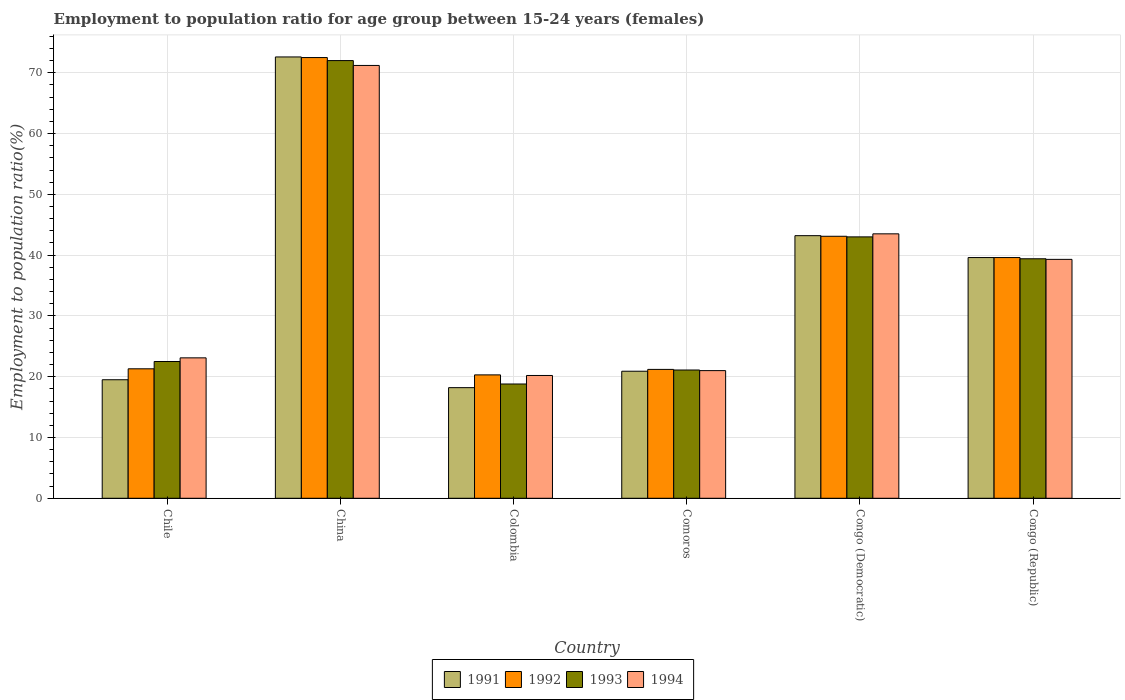Are the number of bars per tick equal to the number of legend labels?
Your answer should be compact. Yes. How many bars are there on the 2nd tick from the left?
Offer a terse response. 4. How many bars are there on the 6th tick from the right?
Your answer should be compact. 4. What is the label of the 1st group of bars from the left?
Make the answer very short. Chile. In how many cases, is the number of bars for a given country not equal to the number of legend labels?
Provide a short and direct response. 0. Across all countries, what is the maximum employment to population ratio in 1991?
Provide a short and direct response. 72.6. Across all countries, what is the minimum employment to population ratio in 1994?
Your answer should be compact. 20.2. In which country was the employment to population ratio in 1992 maximum?
Provide a succinct answer. China. What is the total employment to population ratio in 1994 in the graph?
Ensure brevity in your answer.  218.3. What is the difference between the employment to population ratio in 1993 in China and that in Congo (Republic)?
Keep it short and to the point. 32.6. What is the difference between the employment to population ratio in 1993 in China and the employment to population ratio in 1992 in Chile?
Ensure brevity in your answer.  50.7. What is the average employment to population ratio in 1991 per country?
Provide a short and direct response. 35.67. What is the difference between the employment to population ratio of/in 1994 and employment to population ratio of/in 1991 in China?
Ensure brevity in your answer.  -1.4. What is the ratio of the employment to population ratio in 1994 in Congo (Democratic) to that in Congo (Republic)?
Your answer should be compact. 1.11. Is the difference between the employment to population ratio in 1994 in Chile and Congo (Republic) greater than the difference between the employment to population ratio in 1991 in Chile and Congo (Republic)?
Your answer should be very brief. Yes. What is the difference between the highest and the second highest employment to population ratio in 1991?
Give a very brief answer. 29.4. What is the difference between the highest and the lowest employment to population ratio in 1993?
Provide a short and direct response. 53.2. In how many countries, is the employment to population ratio in 1992 greater than the average employment to population ratio in 1992 taken over all countries?
Give a very brief answer. 3. Is the sum of the employment to population ratio in 1994 in China and Congo (Republic) greater than the maximum employment to population ratio in 1992 across all countries?
Offer a very short reply. Yes. Is it the case that in every country, the sum of the employment to population ratio in 1991 and employment to population ratio in 1994 is greater than the employment to population ratio in 1993?
Make the answer very short. Yes. How many bars are there?
Offer a terse response. 24. What is the difference between two consecutive major ticks on the Y-axis?
Provide a short and direct response. 10. Are the values on the major ticks of Y-axis written in scientific E-notation?
Ensure brevity in your answer.  No. Where does the legend appear in the graph?
Provide a short and direct response. Bottom center. How many legend labels are there?
Your response must be concise. 4. How are the legend labels stacked?
Offer a terse response. Horizontal. What is the title of the graph?
Ensure brevity in your answer.  Employment to population ratio for age group between 15-24 years (females). What is the Employment to population ratio(%) of 1992 in Chile?
Provide a short and direct response. 21.3. What is the Employment to population ratio(%) of 1994 in Chile?
Your response must be concise. 23.1. What is the Employment to population ratio(%) of 1991 in China?
Your answer should be very brief. 72.6. What is the Employment to population ratio(%) of 1992 in China?
Keep it short and to the point. 72.5. What is the Employment to population ratio(%) of 1993 in China?
Ensure brevity in your answer.  72. What is the Employment to population ratio(%) of 1994 in China?
Your answer should be compact. 71.2. What is the Employment to population ratio(%) of 1991 in Colombia?
Offer a very short reply. 18.2. What is the Employment to population ratio(%) in 1992 in Colombia?
Your response must be concise. 20.3. What is the Employment to population ratio(%) in 1993 in Colombia?
Ensure brevity in your answer.  18.8. What is the Employment to population ratio(%) in 1994 in Colombia?
Give a very brief answer. 20.2. What is the Employment to population ratio(%) in 1991 in Comoros?
Provide a short and direct response. 20.9. What is the Employment to population ratio(%) of 1992 in Comoros?
Give a very brief answer. 21.2. What is the Employment to population ratio(%) of 1993 in Comoros?
Your answer should be very brief. 21.1. What is the Employment to population ratio(%) in 1994 in Comoros?
Make the answer very short. 21. What is the Employment to population ratio(%) in 1991 in Congo (Democratic)?
Keep it short and to the point. 43.2. What is the Employment to population ratio(%) in 1992 in Congo (Democratic)?
Your answer should be compact. 43.1. What is the Employment to population ratio(%) in 1994 in Congo (Democratic)?
Your answer should be very brief. 43.5. What is the Employment to population ratio(%) in 1991 in Congo (Republic)?
Ensure brevity in your answer.  39.6. What is the Employment to population ratio(%) of 1992 in Congo (Republic)?
Offer a very short reply. 39.6. What is the Employment to population ratio(%) in 1993 in Congo (Republic)?
Your response must be concise. 39.4. What is the Employment to population ratio(%) in 1994 in Congo (Republic)?
Offer a terse response. 39.3. Across all countries, what is the maximum Employment to population ratio(%) in 1991?
Give a very brief answer. 72.6. Across all countries, what is the maximum Employment to population ratio(%) in 1992?
Offer a terse response. 72.5. Across all countries, what is the maximum Employment to population ratio(%) in 1994?
Ensure brevity in your answer.  71.2. Across all countries, what is the minimum Employment to population ratio(%) in 1991?
Offer a very short reply. 18.2. Across all countries, what is the minimum Employment to population ratio(%) in 1992?
Keep it short and to the point. 20.3. Across all countries, what is the minimum Employment to population ratio(%) in 1993?
Keep it short and to the point. 18.8. Across all countries, what is the minimum Employment to population ratio(%) of 1994?
Keep it short and to the point. 20.2. What is the total Employment to population ratio(%) of 1991 in the graph?
Your answer should be very brief. 214. What is the total Employment to population ratio(%) in 1992 in the graph?
Your response must be concise. 218. What is the total Employment to population ratio(%) of 1993 in the graph?
Offer a very short reply. 216.8. What is the total Employment to population ratio(%) in 1994 in the graph?
Your answer should be very brief. 218.3. What is the difference between the Employment to population ratio(%) of 1991 in Chile and that in China?
Make the answer very short. -53.1. What is the difference between the Employment to population ratio(%) in 1992 in Chile and that in China?
Offer a terse response. -51.2. What is the difference between the Employment to population ratio(%) of 1993 in Chile and that in China?
Your answer should be compact. -49.5. What is the difference between the Employment to population ratio(%) of 1994 in Chile and that in China?
Offer a terse response. -48.1. What is the difference between the Employment to population ratio(%) in 1991 in Chile and that in Colombia?
Keep it short and to the point. 1.3. What is the difference between the Employment to population ratio(%) in 1994 in Chile and that in Colombia?
Provide a succinct answer. 2.9. What is the difference between the Employment to population ratio(%) of 1991 in Chile and that in Congo (Democratic)?
Offer a terse response. -23.7. What is the difference between the Employment to population ratio(%) of 1992 in Chile and that in Congo (Democratic)?
Offer a terse response. -21.8. What is the difference between the Employment to population ratio(%) in 1993 in Chile and that in Congo (Democratic)?
Provide a short and direct response. -20.5. What is the difference between the Employment to population ratio(%) in 1994 in Chile and that in Congo (Democratic)?
Offer a terse response. -20.4. What is the difference between the Employment to population ratio(%) of 1991 in Chile and that in Congo (Republic)?
Your answer should be very brief. -20.1. What is the difference between the Employment to population ratio(%) of 1992 in Chile and that in Congo (Republic)?
Offer a very short reply. -18.3. What is the difference between the Employment to population ratio(%) in 1993 in Chile and that in Congo (Republic)?
Ensure brevity in your answer.  -16.9. What is the difference between the Employment to population ratio(%) of 1994 in Chile and that in Congo (Republic)?
Your answer should be very brief. -16.2. What is the difference between the Employment to population ratio(%) of 1991 in China and that in Colombia?
Provide a short and direct response. 54.4. What is the difference between the Employment to population ratio(%) in 1992 in China and that in Colombia?
Your answer should be compact. 52.2. What is the difference between the Employment to population ratio(%) of 1993 in China and that in Colombia?
Keep it short and to the point. 53.2. What is the difference between the Employment to population ratio(%) of 1991 in China and that in Comoros?
Ensure brevity in your answer.  51.7. What is the difference between the Employment to population ratio(%) of 1992 in China and that in Comoros?
Provide a short and direct response. 51.3. What is the difference between the Employment to population ratio(%) of 1993 in China and that in Comoros?
Your answer should be compact. 50.9. What is the difference between the Employment to population ratio(%) of 1994 in China and that in Comoros?
Your answer should be very brief. 50.2. What is the difference between the Employment to population ratio(%) of 1991 in China and that in Congo (Democratic)?
Your response must be concise. 29.4. What is the difference between the Employment to population ratio(%) of 1992 in China and that in Congo (Democratic)?
Your answer should be compact. 29.4. What is the difference between the Employment to population ratio(%) of 1994 in China and that in Congo (Democratic)?
Provide a short and direct response. 27.7. What is the difference between the Employment to population ratio(%) in 1992 in China and that in Congo (Republic)?
Provide a succinct answer. 32.9. What is the difference between the Employment to population ratio(%) in 1993 in China and that in Congo (Republic)?
Make the answer very short. 32.6. What is the difference between the Employment to population ratio(%) in 1994 in China and that in Congo (Republic)?
Your response must be concise. 31.9. What is the difference between the Employment to population ratio(%) in 1994 in Colombia and that in Comoros?
Offer a terse response. -0.8. What is the difference between the Employment to population ratio(%) of 1991 in Colombia and that in Congo (Democratic)?
Offer a terse response. -25. What is the difference between the Employment to population ratio(%) of 1992 in Colombia and that in Congo (Democratic)?
Your response must be concise. -22.8. What is the difference between the Employment to population ratio(%) in 1993 in Colombia and that in Congo (Democratic)?
Keep it short and to the point. -24.2. What is the difference between the Employment to population ratio(%) of 1994 in Colombia and that in Congo (Democratic)?
Offer a very short reply. -23.3. What is the difference between the Employment to population ratio(%) of 1991 in Colombia and that in Congo (Republic)?
Your answer should be very brief. -21.4. What is the difference between the Employment to population ratio(%) in 1992 in Colombia and that in Congo (Republic)?
Your answer should be compact. -19.3. What is the difference between the Employment to population ratio(%) in 1993 in Colombia and that in Congo (Republic)?
Your answer should be very brief. -20.6. What is the difference between the Employment to population ratio(%) in 1994 in Colombia and that in Congo (Republic)?
Your response must be concise. -19.1. What is the difference between the Employment to population ratio(%) of 1991 in Comoros and that in Congo (Democratic)?
Your answer should be very brief. -22.3. What is the difference between the Employment to population ratio(%) in 1992 in Comoros and that in Congo (Democratic)?
Provide a short and direct response. -21.9. What is the difference between the Employment to population ratio(%) of 1993 in Comoros and that in Congo (Democratic)?
Keep it short and to the point. -21.9. What is the difference between the Employment to population ratio(%) in 1994 in Comoros and that in Congo (Democratic)?
Ensure brevity in your answer.  -22.5. What is the difference between the Employment to population ratio(%) of 1991 in Comoros and that in Congo (Republic)?
Offer a very short reply. -18.7. What is the difference between the Employment to population ratio(%) in 1992 in Comoros and that in Congo (Republic)?
Keep it short and to the point. -18.4. What is the difference between the Employment to population ratio(%) of 1993 in Comoros and that in Congo (Republic)?
Your answer should be very brief. -18.3. What is the difference between the Employment to population ratio(%) of 1994 in Comoros and that in Congo (Republic)?
Provide a succinct answer. -18.3. What is the difference between the Employment to population ratio(%) in 1991 in Congo (Democratic) and that in Congo (Republic)?
Your response must be concise. 3.6. What is the difference between the Employment to population ratio(%) of 1993 in Congo (Democratic) and that in Congo (Republic)?
Your response must be concise. 3.6. What is the difference between the Employment to population ratio(%) in 1991 in Chile and the Employment to population ratio(%) in 1992 in China?
Your answer should be compact. -53. What is the difference between the Employment to population ratio(%) in 1991 in Chile and the Employment to population ratio(%) in 1993 in China?
Your answer should be compact. -52.5. What is the difference between the Employment to population ratio(%) of 1991 in Chile and the Employment to population ratio(%) of 1994 in China?
Your answer should be compact. -51.7. What is the difference between the Employment to population ratio(%) in 1992 in Chile and the Employment to population ratio(%) in 1993 in China?
Give a very brief answer. -50.7. What is the difference between the Employment to population ratio(%) of 1992 in Chile and the Employment to population ratio(%) of 1994 in China?
Keep it short and to the point. -49.9. What is the difference between the Employment to population ratio(%) of 1993 in Chile and the Employment to population ratio(%) of 1994 in China?
Keep it short and to the point. -48.7. What is the difference between the Employment to population ratio(%) in 1991 in Chile and the Employment to population ratio(%) in 1992 in Colombia?
Provide a short and direct response. -0.8. What is the difference between the Employment to population ratio(%) of 1992 in Chile and the Employment to population ratio(%) of 1994 in Colombia?
Keep it short and to the point. 1.1. What is the difference between the Employment to population ratio(%) of 1993 in Chile and the Employment to population ratio(%) of 1994 in Colombia?
Your response must be concise. 2.3. What is the difference between the Employment to population ratio(%) of 1992 in Chile and the Employment to population ratio(%) of 1993 in Comoros?
Keep it short and to the point. 0.2. What is the difference between the Employment to population ratio(%) in 1993 in Chile and the Employment to population ratio(%) in 1994 in Comoros?
Provide a short and direct response. 1.5. What is the difference between the Employment to population ratio(%) of 1991 in Chile and the Employment to population ratio(%) of 1992 in Congo (Democratic)?
Give a very brief answer. -23.6. What is the difference between the Employment to population ratio(%) of 1991 in Chile and the Employment to population ratio(%) of 1993 in Congo (Democratic)?
Make the answer very short. -23.5. What is the difference between the Employment to population ratio(%) in 1991 in Chile and the Employment to population ratio(%) in 1994 in Congo (Democratic)?
Keep it short and to the point. -24. What is the difference between the Employment to population ratio(%) of 1992 in Chile and the Employment to population ratio(%) of 1993 in Congo (Democratic)?
Ensure brevity in your answer.  -21.7. What is the difference between the Employment to population ratio(%) in 1992 in Chile and the Employment to population ratio(%) in 1994 in Congo (Democratic)?
Ensure brevity in your answer.  -22.2. What is the difference between the Employment to population ratio(%) in 1991 in Chile and the Employment to population ratio(%) in 1992 in Congo (Republic)?
Offer a very short reply. -20.1. What is the difference between the Employment to population ratio(%) in 1991 in Chile and the Employment to population ratio(%) in 1993 in Congo (Republic)?
Offer a very short reply. -19.9. What is the difference between the Employment to population ratio(%) of 1991 in Chile and the Employment to population ratio(%) of 1994 in Congo (Republic)?
Your answer should be very brief. -19.8. What is the difference between the Employment to population ratio(%) in 1992 in Chile and the Employment to population ratio(%) in 1993 in Congo (Republic)?
Make the answer very short. -18.1. What is the difference between the Employment to population ratio(%) in 1992 in Chile and the Employment to population ratio(%) in 1994 in Congo (Republic)?
Provide a succinct answer. -18. What is the difference between the Employment to population ratio(%) in 1993 in Chile and the Employment to population ratio(%) in 1994 in Congo (Republic)?
Make the answer very short. -16.8. What is the difference between the Employment to population ratio(%) in 1991 in China and the Employment to population ratio(%) in 1992 in Colombia?
Provide a succinct answer. 52.3. What is the difference between the Employment to population ratio(%) of 1991 in China and the Employment to population ratio(%) of 1993 in Colombia?
Provide a succinct answer. 53.8. What is the difference between the Employment to population ratio(%) in 1991 in China and the Employment to population ratio(%) in 1994 in Colombia?
Make the answer very short. 52.4. What is the difference between the Employment to population ratio(%) in 1992 in China and the Employment to population ratio(%) in 1993 in Colombia?
Keep it short and to the point. 53.7. What is the difference between the Employment to population ratio(%) in 1992 in China and the Employment to population ratio(%) in 1994 in Colombia?
Ensure brevity in your answer.  52.3. What is the difference between the Employment to population ratio(%) of 1993 in China and the Employment to population ratio(%) of 1994 in Colombia?
Ensure brevity in your answer.  51.8. What is the difference between the Employment to population ratio(%) in 1991 in China and the Employment to population ratio(%) in 1992 in Comoros?
Offer a terse response. 51.4. What is the difference between the Employment to population ratio(%) of 1991 in China and the Employment to population ratio(%) of 1993 in Comoros?
Provide a short and direct response. 51.5. What is the difference between the Employment to population ratio(%) of 1991 in China and the Employment to population ratio(%) of 1994 in Comoros?
Offer a terse response. 51.6. What is the difference between the Employment to population ratio(%) in 1992 in China and the Employment to population ratio(%) in 1993 in Comoros?
Offer a very short reply. 51.4. What is the difference between the Employment to population ratio(%) of 1992 in China and the Employment to population ratio(%) of 1994 in Comoros?
Provide a succinct answer. 51.5. What is the difference between the Employment to population ratio(%) of 1991 in China and the Employment to population ratio(%) of 1992 in Congo (Democratic)?
Ensure brevity in your answer.  29.5. What is the difference between the Employment to population ratio(%) of 1991 in China and the Employment to population ratio(%) of 1993 in Congo (Democratic)?
Make the answer very short. 29.6. What is the difference between the Employment to population ratio(%) of 1991 in China and the Employment to population ratio(%) of 1994 in Congo (Democratic)?
Offer a very short reply. 29.1. What is the difference between the Employment to population ratio(%) of 1992 in China and the Employment to population ratio(%) of 1993 in Congo (Democratic)?
Your answer should be compact. 29.5. What is the difference between the Employment to population ratio(%) in 1992 in China and the Employment to population ratio(%) in 1994 in Congo (Democratic)?
Your answer should be compact. 29. What is the difference between the Employment to population ratio(%) in 1991 in China and the Employment to population ratio(%) in 1992 in Congo (Republic)?
Provide a succinct answer. 33. What is the difference between the Employment to population ratio(%) of 1991 in China and the Employment to population ratio(%) of 1993 in Congo (Republic)?
Give a very brief answer. 33.2. What is the difference between the Employment to population ratio(%) in 1991 in China and the Employment to population ratio(%) in 1994 in Congo (Republic)?
Offer a terse response. 33.3. What is the difference between the Employment to population ratio(%) in 1992 in China and the Employment to population ratio(%) in 1993 in Congo (Republic)?
Offer a very short reply. 33.1. What is the difference between the Employment to population ratio(%) in 1992 in China and the Employment to population ratio(%) in 1994 in Congo (Republic)?
Provide a short and direct response. 33.2. What is the difference between the Employment to population ratio(%) of 1993 in China and the Employment to population ratio(%) of 1994 in Congo (Republic)?
Ensure brevity in your answer.  32.7. What is the difference between the Employment to population ratio(%) of 1991 in Colombia and the Employment to population ratio(%) of 1994 in Comoros?
Your response must be concise. -2.8. What is the difference between the Employment to population ratio(%) in 1992 in Colombia and the Employment to population ratio(%) in 1993 in Comoros?
Offer a terse response. -0.8. What is the difference between the Employment to population ratio(%) in 1992 in Colombia and the Employment to population ratio(%) in 1994 in Comoros?
Keep it short and to the point. -0.7. What is the difference between the Employment to population ratio(%) of 1993 in Colombia and the Employment to population ratio(%) of 1994 in Comoros?
Your response must be concise. -2.2. What is the difference between the Employment to population ratio(%) of 1991 in Colombia and the Employment to population ratio(%) of 1992 in Congo (Democratic)?
Provide a short and direct response. -24.9. What is the difference between the Employment to population ratio(%) of 1991 in Colombia and the Employment to population ratio(%) of 1993 in Congo (Democratic)?
Provide a short and direct response. -24.8. What is the difference between the Employment to population ratio(%) of 1991 in Colombia and the Employment to population ratio(%) of 1994 in Congo (Democratic)?
Your answer should be compact. -25.3. What is the difference between the Employment to population ratio(%) of 1992 in Colombia and the Employment to population ratio(%) of 1993 in Congo (Democratic)?
Keep it short and to the point. -22.7. What is the difference between the Employment to population ratio(%) in 1992 in Colombia and the Employment to population ratio(%) in 1994 in Congo (Democratic)?
Offer a very short reply. -23.2. What is the difference between the Employment to population ratio(%) of 1993 in Colombia and the Employment to population ratio(%) of 1994 in Congo (Democratic)?
Offer a terse response. -24.7. What is the difference between the Employment to population ratio(%) of 1991 in Colombia and the Employment to population ratio(%) of 1992 in Congo (Republic)?
Give a very brief answer. -21.4. What is the difference between the Employment to population ratio(%) of 1991 in Colombia and the Employment to population ratio(%) of 1993 in Congo (Republic)?
Provide a short and direct response. -21.2. What is the difference between the Employment to population ratio(%) in 1991 in Colombia and the Employment to population ratio(%) in 1994 in Congo (Republic)?
Provide a succinct answer. -21.1. What is the difference between the Employment to population ratio(%) of 1992 in Colombia and the Employment to population ratio(%) of 1993 in Congo (Republic)?
Provide a short and direct response. -19.1. What is the difference between the Employment to population ratio(%) in 1992 in Colombia and the Employment to population ratio(%) in 1994 in Congo (Republic)?
Your answer should be compact. -19. What is the difference between the Employment to population ratio(%) in 1993 in Colombia and the Employment to population ratio(%) in 1994 in Congo (Republic)?
Make the answer very short. -20.5. What is the difference between the Employment to population ratio(%) in 1991 in Comoros and the Employment to population ratio(%) in 1992 in Congo (Democratic)?
Your answer should be compact. -22.2. What is the difference between the Employment to population ratio(%) in 1991 in Comoros and the Employment to population ratio(%) in 1993 in Congo (Democratic)?
Your answer should be very brief. -22.1. What is the difference between the Employment to population ratio(%) of 1991 in Comoros and the Employment to population ratio(%) of 1994 in Congo (Democratic)?
Provide a short and direct response. -22.6. What is the difference between the Employment to population ratio(%) of 1992 in Comoros and the Employment to population ratio(%) of 1993 in Congo (Democratic)?
Provide a short and direct response. -21.8. What is the difference between the Employment to population ratio(%) of 1992 in Comoros and the Employment to population ratio(%) of 1994 in Congo (Democratic)?
Your answer should be very brief. -22.3. What is the difference between the Employment to population ratio(%) in 1993 in Comoros and the Employment to population ratio(%) in 1994 in Congo (Democratic)?
Give a very brief answer. -22.4. What is the difference between the Employment to population ratio(%) in 1991 in Comoros and the Employment to population ratio(%) in 1992 in Congo (Republic)?
Provide a short and direct response. -18.7. What is the difference between the Employment to population ratio(%) of 1991 in Comoros and the Employment to population ratio(%) of 1993 in Congo (Republic)?
Provide a short and direct response. -18.5. What is the difference between the Employment to population ratio(%) of 1991 in Comoros and the Employment to population ratio(%) of 1994 in Congo (Republic)?
Your answer should be compact. -18.4. What is the difference between the Employment to population ratio(%) in 1992 in Comoros and the Employment to population ratio(%) in 1993 in Congo (Republic)?
Offer a very short reply. -18.2. What is the difference between the Employment to population ratio(%) of 1992 in Comoros and the Employment to population ratio(%) of 1994 in Congo (Republic)?
Keep it short and to the point. -18.1. What is the difference between the Employment to population ratio(%) in 1993 in Comoros and the Employment to population ratio(%) in 1994 in Congo (Republic)?
Provide a short and direct response. -18.2. What is the difference between the Employment to population ratio(%) in 1991 in Congo (Democratic) and the Employment to population ratio(%) in 1993 in Congo (Republic)?
Offer a very short reply. 3.8. What is the difference between the Employment to population ratio(%) of 1992 in Congo (Democratic) and the Employment to population ratio(%) of 1993 in Congo (Republic)?
Offer a terse response. 3.7. What is the difference between the Employment to population ratio(%) in 1993 in Congo (Democratic) and the Employment to population ratio(%) in 1994 in Congo (Republic)?
Offer a terse response. 3.7. What is the average Employment to population ratio(%) in 1991 per country?
Ensure brevity in your answer.  35.67. What is the average Employment to population ratio(%) in 1992 per country?
Ensure brevity in your answer.  36.33. What is the average Employment to population ratio(%) in 1993 per country?
Your answer should be very brief. 36.13. What is the average Employment to population ratio(%) of 1994 per country?
Provide a short and direct response. 36.38. What is the difference between the Employment to population ratio(%) of 1991 and Employment to population ratio(%) of 1992 in Chile?
Offer a terse response. -1.8. What is the difference between the Employment to population ratio(%) in 1992 and Employment to population ratio(%) in 1993 in Chile?
Offer a very short reply. -1.2. What is the difference between the Employment to population ratio(%) of 1991 and Employment to population ratio(%) of 1993 in China?
Your answer should be very brief. 0.6. What is the difference between the Employment to population ratio(%) in 1992 and Employment to population ratio(%) in 1993 in China?
Offer a very short reply. 0.5. What is the difference between the Employment to population ratio(%) in 1992 and Employment to population ratio(%) in 1994 in China?
Your answer should be very brief. 1.3. What is the difference between the Employment to population ratio(%) in 1993 and Employment to population ratio(%) in 1994 in China?
Make the answer very short. 0.8. What is the difference between the Employment to population ratio(%) in 1991 and Employment to population ratio(%) in 1992 in Colombia?
Offer a very short reply. -2.1. What is the difference between the Employment to population ratio(%) in 1991 and Employment to population ratio(%) in 1994 in Colombia?
Provide a short and direct response. -2. What is the difference between the Employment to population ratio(%) of 1992 and Employment to population ratio(%) of 1994 in Colombia?
Your response must be concise. 0.1. What is the difference between the Employment to population ratio(%) of 1993 and Employment to population ratio(%) of 1994 in Colombia?
Your response must be concise. -1.4. What is the difference between the Employment to population ratio(%) of 1991 and Employment to population ratio(%) of 1992 in Comoros?
Make the answer very short. -0.3. What is the difference between the Employment to population ratio(%) of 1991 and Employment to population ratio(%) of 1993 in Comoros?
Give a very brief answer. -0.2. What is the difference between the Employment to population ratio(%) of 1993 and Employment to population ratio(%) of 1994 in Comoros?
Your answer should be very brief. 0.1. What is the difference between the Employment to population ratio(%) in 1991 and Employment to population ratio(%) in 1992 in Congo (Democratic)?
Your response must be concise. 0.1. What is the difference between the Employment to population ratio(%) in 1991 and Employment to population ratio(%) in 1993 in Congo (Democratic)?
Provide a succinct answer. 0.2. What is the difference between the Employment to population ratio(%) in 1992 and Employment to population ratio(%) in 1993 in Congo (Democratic)?
Your answer should be very brief. 0.1. What is the difference between the Employment to population ratio(%) in 1992 and Employment to population ratio(%) in 1994 in Congo (Democratic)?
Give a very brief answer. -0.4. What is the difference between the Employment to population ratio(%) in 1991 and Employment to population ratio(%) in 1993 in Congo (Republic)?
Your answer should be compact. 0.2. What is the difference between the Employment to population ratio(%) in 1991 and Employment to population ratio(%) in 1994 in Congo (Republic)?
Provide a succinct answer. 0.3. What is the difference between the Employment to population ratio(%) in 1992 and Employment to population ratio(%) in 1994 in Congo (Republic)?
Keep it short and to the point. 0.3. What is the ratio of the Employment to population ratio(%) in 1991 in Chile to that in China?
Your answer should be very brief. 0.27. What is the ratio of the Employment to population ratio(%) of 1992 in Chile to that in China?
Give a very brief answer. 0.29. What is the ratio of the Employment to population ratio(%) of 1993 in Chile to that in China?
Your answer should be very brief. 0.31. What is the ratio of the Employment to population ratio(%) of 1994 in Chile to that in China?
Your answer should be compact. 0.32. What is the ratio of the Employment to population ratio(%) of 1991 in Chile to that in Colombia?
Make the answer very short. 1.07. What is the ratio of the Employment to population ratio(%) in 1992 in Chile to that in Colombia?
Keep it short and to the point. 1.05. What is the ratio of the Employment to population ratio(%) of 1993 in Chile to that in Colombia?
Ensure brevity in your answer.  1.2. What is the ratio of the Employment to population ratio(%) in 1994 in Chile to that in Colombia?
Your answer should be very brief. 1.14. What is the ratio of the Employment to population ratio(%) of 1991 in Chile to that in Comoros?
Provide a short and direct response. 0.93. What is the ratio of the Employment to population ratio(%) in 1992 in Chile to that in Comoros?
Make the answer very short. 1. What is the ratio of the Employment to population ratio(%) of 1993 in Chile to that in Comoros?
Provide a short and direct response. 1.07. What is the ratio of the Employment to population ratio(%) of 1991 in Chile to that in Congo (Democratic)?
Your answer should be compact. 0.45. What is the ratio of the Employment to population ratio(%) in 1992 in Chile to that in Congo (Democratic)?
Ensure brevity in your answer.  0.49. What is the ratio of the Employment to population ratio(%) of 1993 in Chile to that in Congo (Democratic)?
Ensure brevity in your answer.  0.52. What is the ratio of the Employment to population ratio(%) in 1994 in Chile to that in Congo (Democratic)?
Provide a succinct answer. 0.53. What is the ratio of the Employment to population ratio(%) in 1991 in Chile to that in Congo (Republic)?
Your answer should be very brief. 0.49. What is the ratio of the Employment to population ratio(%) of 1992 in Chile to that in Congo (Republic)?
Ensure brevity in your answer.  0.54. What is the ratio of the Employment to population ratio(%) in 1993 in Chile to that in Congo (Republic)?
Your answer should be compact. 0.57. What is the ratio of the Employment to population ratio(%) of 1994 in Chile to that in Congo (Republic)?
Ensure brevity in your answer.  0.59. What is the ratio of the Employment to population ratio(%) in 1991 in China to that in Colombia?
Provide a succinct answer. 3.99. What is the ratio of the Employment to population ratio(%) in 1992 in China to that in Colombia?
Your response must be concise. 3.57. What is the ratio of the Employment to population ratio(%) of 1993 in China to that in Colombia?
Provide a short and direct response. 3.83. What is the ratio of the Employment to population ratio(%) of 1994 in China to that in Colombia?
Offer a terse response. 3.52. What is the ratio of the Employment to population ratio(%) of 1991 in China to that in Comoros?
Provide a short and direct response. 3.47. What is the ratio of the Employment to population ratio(%) of 1992 in China to that in Comoros?
Ensure brevity in your answer.  3.42. What is the ratio of the Employment to population ratio(%) of 1993 in China to that in Comoros?
Make the answer very short. 3.41. What is the ratio of the Employment to population ratio(%) in 1994 in China to that in Comoros?
Keep it short and to the point. 3.39. What is the ratio of the Employment to population ratio(%) of 1991 in China to that in Congo (Democratic)?
Provide a short and direct response. 1.68. What is the ratio of the Employment to population ratio(%) in 1992 in China to that in Congo (Democratic)?
Make the answer very short. 1.68. What is the ratio of the Employment to population ratio(%) in 1993 in China to that in Congo (Democratic)?
Ensure brevity in your answer.  1.67. What is the ratio of the Employment to population ratio(%) in 1994 in China to that in Congo (Democratic)?
Offer a very short reply. 1.64. What is the ratio of the Employment to population ratio(%) in 1991 in China to that in Congo (Republic)?
Offer a very short reply. 1.83. What is the ratio of the Employment to population ratio(%) of 1992 in China to that in Congo (Republic)?
Your response must be concise. 1.83. What is the ratio of the Employment to population ratio(%) of 1993 in China to that in Congo (Republic)?
Keep it short and to the point. 1.83. What is the ratio of the Employment to population ratio(%) of 1994 in China to that in Congo (Republic)?
Provide a short and direct response. 1.81. What is the ratio of the Employment to population ratio(%) of 1991 in Colombia to that in Comoros?
Provide a succinct answer. 0.87. What is the ratio of the Employment to population ratio(%) of 1992 in Colombia to that in Comoros?
Ensure brevity in your answer.  0.96. What is the ratio of the Employment to population ratio(%) of 1993 in Colombia to that in Comoros?
Your response must be concise. 0.89. What is the ratio of the Employment to population ratio(%) of 1994 in Colombia to that in Comoros?
Offer a very short reply. 0.96. What is the ratio of the Employment to population ratio(%) of 1991 in Colombia to that in Congo (Democratic)?
Ensure brevity in your answer.  0.42. What is the ratio of the Employment to population ratio(%) of 1992 in Colombia to that in Congo (Democratic)?
Your answer should be compact. 0.47. What is the ratio of the Employment to population ratio(%) in 1993 in Colombia to that in Congo (Democratic)?
Your answer should be very brief. 0.44. What is the ratio of the Employment to population ratio(%) of 1994 in Colombia to that in Congo (Democratic)?
Your response must be concise. 0.46. What is the ratio of the Employment to population ratio(%) in 1991 in Colombia to that in Congo (Republic)?
Ensure brevity in your answer.  0.46. What is the ratio of the Employment to population ratio(%) in 1992 in Colombia to that in Congo (Republic)?
Keep it short and to the point. 0.51. What is the ratio of the Employment to population ratio(%) in 1993 in Colombia to that in Congo (Republic)?
Ensure brevity in your answer.  0.48. What is the ratio of the Employment to population ratio(%) in 1994 in Colombia to that in Congo (Republic)?
Provide a succinct answer. 0.51. What is the ratio of the Employment to population ratio(%) in 1991 in Comoros to that in Congo (Democratic)?
Keep it short and to the point. 0.48. What is the ratio of the Employment to population ratio(%) in 1992 in Comoros to that in Congo (Democratic)?
Ensure brevity in your answer.  0.49. What is the ratio of the Employment to population ratio(%) of 1993 in Comoros to that in Congo (Democratic)?
Offer a terse response. 0.49. What is the ratio of the Employment to population ratio(%) in 1994 in Comoros to that in Congo (Democratic)?
Your answer should be very brief. 0.48. What is the ratio of the Employment to population ratio(%) in 1991 in Comoros to that in Congo (Republic)?
Your answer should be very brief. 0.53. What is the ratio of the Employment to population ratio(%) in 1992 in Comoros to that in Congo (Republic)?
Your answer should be very brief. 0.54. What is the ratio of the Employment to population ratio(%) of 1993 in Comoros to that in Congo (Republic)?
Offer a very short reply. 0.54. What is the ratio of the Employment to population ratio(%) in 1994 in Comoros to that in Congo (Republic)?
Your answer should be compact. 0.53. What is the ratio of the Employment to population ratio(%) of 1991 in Congo (Democratic) to that in Congo (Republic)?
Offer a very short reply. 1.09. What is the ratio of the Employment to population ratio(%) in 1992 in Congo (Democratic) to that in Congo (Republic)?
Your answer should be compact. 1.09. What is the ratio of the Employment to population ratio(%) of 1993 in Congo (Democratic) to that in Congo (Republic)?
Provide a succinct answer. 1.09. What is the ratio of the Employment to population ratio(%) of 1994 in Congo (Democratic) to that in Congo (Republic)?
Give a very brief answer. 1.11. What is the difference between the highest and the second highest Employment to population ratio(%) in 1991?
Ensure brevity in your answer.  29.4. What is the difference between the highest and the second highest Employment to population ratio(%) of 1992?
Your answer should be compact. 29.4. What is the difference between the highest and the second highest Employment to population ratio(%) of 1993?
Offer a very short reply. 29. What is the difference between the highest and the second highest Employment to population ratio(%) in 1994?
Give a very brief answer. 27.7. What is the difference between the highest and the lowest Employment to population ratio(%) in 1991?
Your answer should be compact. 54.4. What is the difference between the highest and the lowest Employment to population ratio(%) of 1992?
Your response must be concise. 52.2. What is the difference between the highest and the lowest Employment to population ratio(%) in 1993?
Provide a short and direct response. 53.2. What is the difference between the highest and the lowest Employment to population ratio(%) of 1994?
Offer a very short reply. 51. 